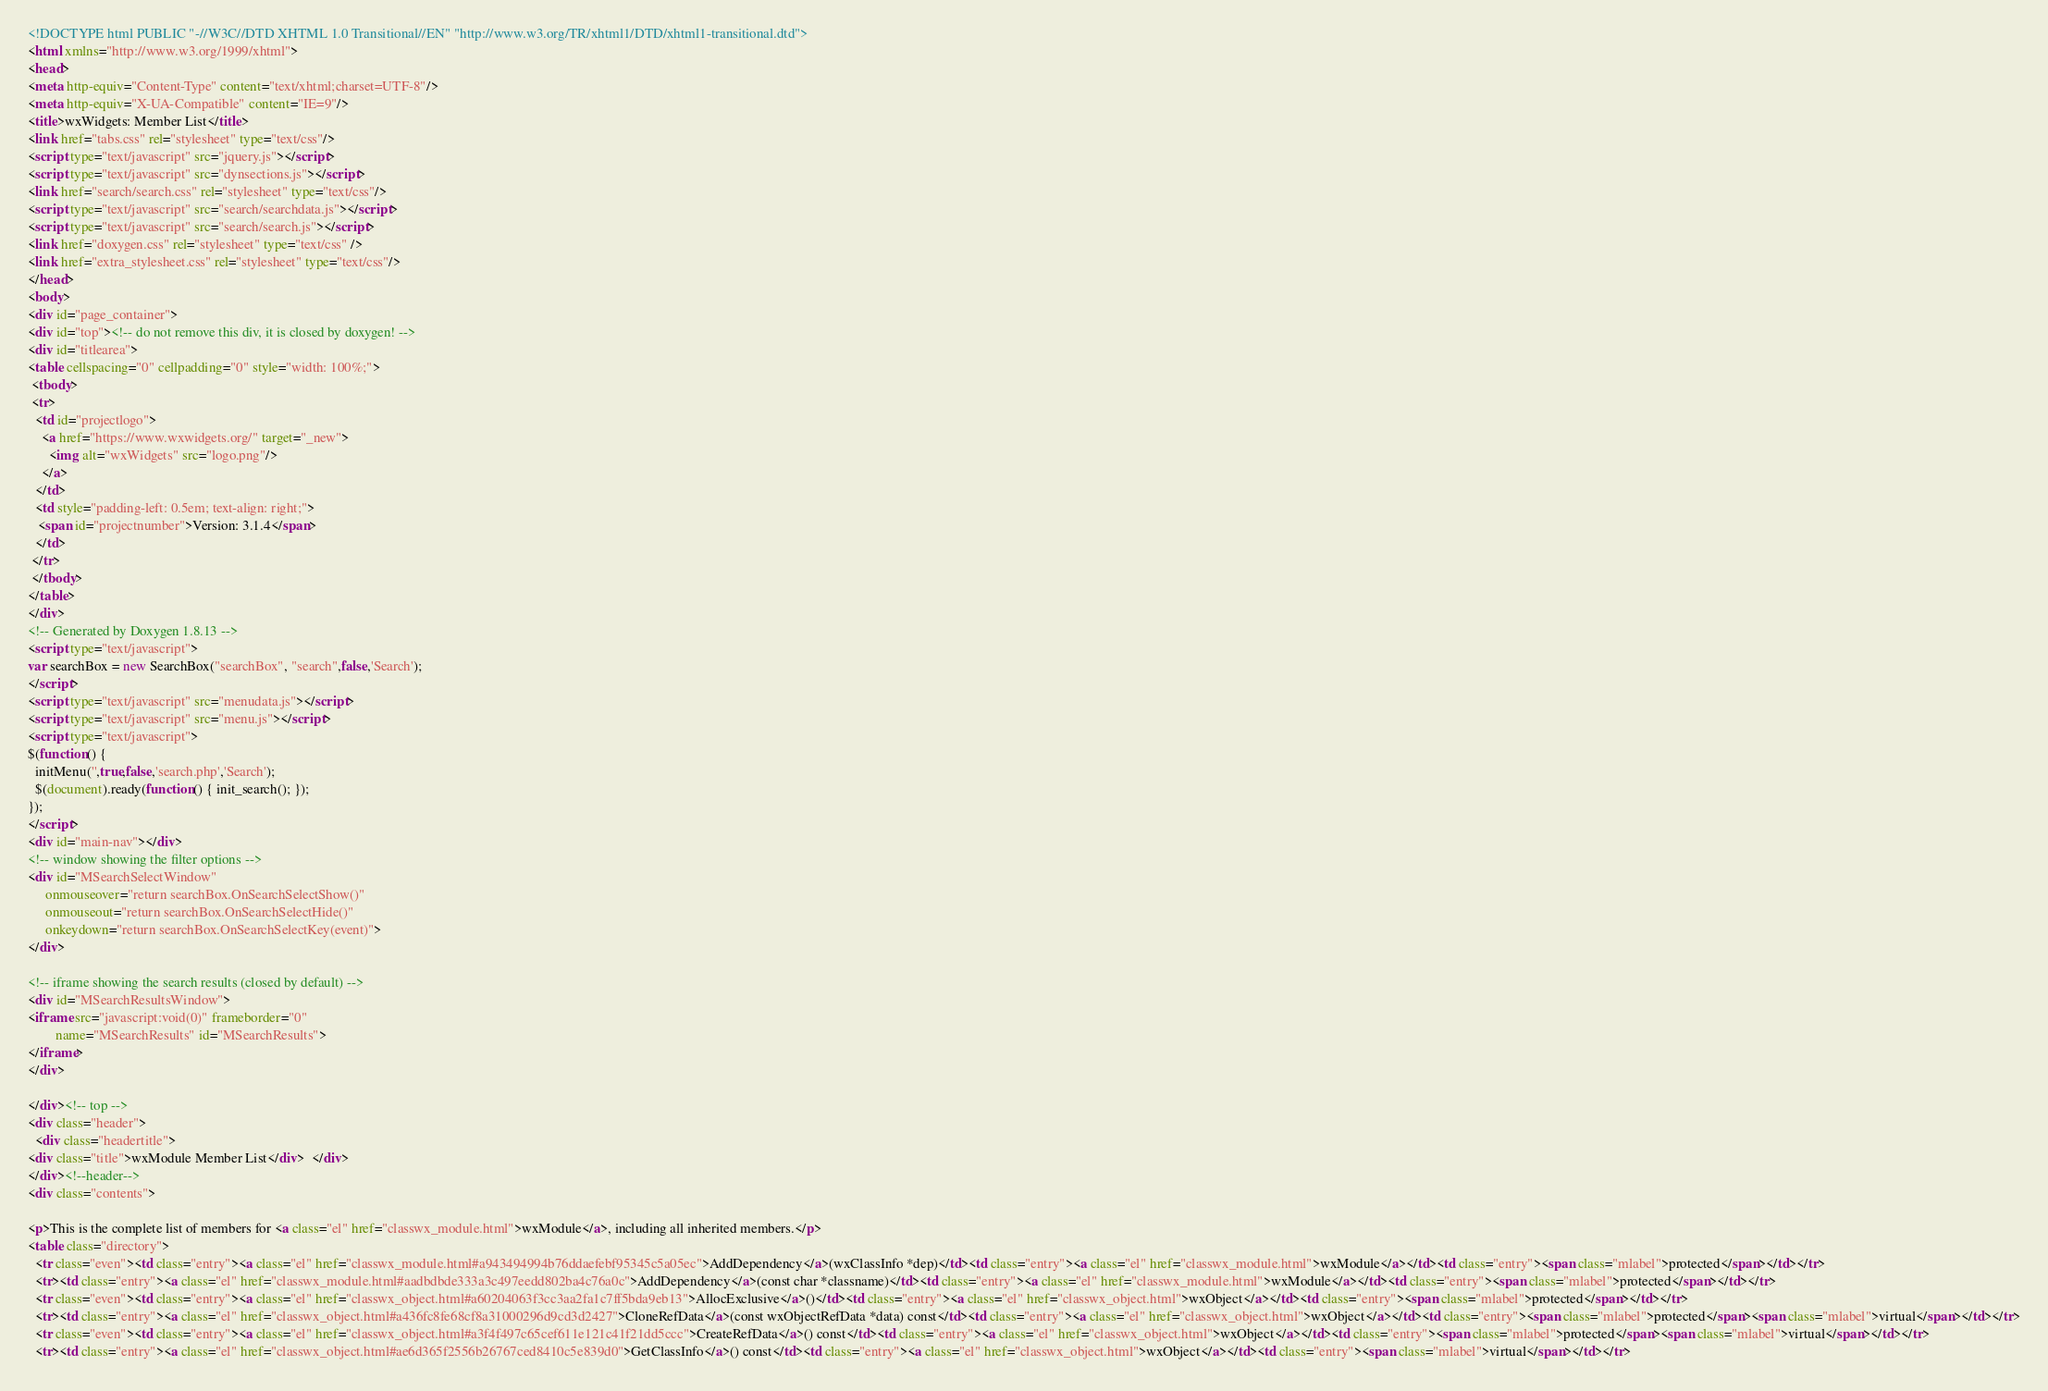Convert code to text. <code><loc_0><loc_0><loc_500><loc_500><_HTML_><!DOCTYPE html PUBLIC "-//W3C//DTD XHTML 1.0 Transitional//EN" "http://www.w3.org/TR/xhtml1/DTD/xhtml1-transitional.dtd">
<html xmlns="http://www.w3.org/1999/xhtml">
<head>
<meta http-equiv="Content-Type" content="text/xhtml;charset=UTF-8"/>
<meta http-equiv="X-UA-Compatible" content="IE=9"/>
<title>wxWidgets: Member List</title>
<link href="tabs.css" rel="stylesheet" type="text/css"/>
<script type="text/javascript" src="jquery.js"></script>
<script type="text/javascript" src="dynsections.js"></script>
<link href="search/search.css" rel="stylesheet" type="text/css"/>
<script type="text/javascript" src="search/searchdata.js"></script>
<script type="text/javascript" src="search/search.js"></script>
<link href="doxygen.css" rel="stylesheet" type="text/css" />
<link href="extra_stylesheet.css" rel="stylesheet" type="text/css"/>
</head>
<body>
<div id="page_container">
<div id="top"><!-- do not remove this div, it is closed by doxygen! -->
<div id="titlearea">
<table cellspacing="0" cellpadding="0" style="width: 100%;">
 <tbody>
 <tr>
  <td id="projectlogo">
    <a href="https://www.wxwidgets.org/" target="_new">
      <img alt="wxWidgets" src="logo.png"/>
    </a>
  </td>
  <td style="padding-left: 0.5em; text-align: right;">
   <span id="projectnumber">Version: 3.1.4</span>
  </td>
 </tr>
 </tbody>
</table>
</div>
<!-- Generated by Doxygen 1.8.13 -->
<script type="text/javascript">
var searchBox = new SearchBox("searchBox", "search",false,'Search');
</script>
<script type="text/javascript" src="menudata.js"></script>
<script type="text/javascript" src="menu.js"></script>
<script type="text/javascript">
$(function() {
  initMenu('',true,false,'search.php','Search');
  $(document).ready(function() { init_search(); });
});
</script>
<div id="main-nav"></div>
<!-- window showing the filter options -->
<div id="MSearchSelectWindow"
     onmouseover="return searchBox.OnSearchSelectShow()"
     onmouseout="return searchBox.OnSearchSelectHide()"
     onkeydown="return searchBox.OnSearchSelectKey(event)">
</div>

<!-- iframe showing the search results (closed by default) -->
<div id="MSearchResultsWindow">
<iframe src="javascript:void(0)" frameborder="0" 
        name="MSearchResults" id="MSearchResults">
</iframe>
</div>

</div><!-- top -->
<div class="header">
  <div class="headertitle">
<div class="title">wxModule Member List</div>  </div>
</div><!--header-->
<div class="contents">

<p>This is the complete list of members for <a class="el" href="classwx_module.html">wxModule</a>, including all inherited members.</p>
<table class="directory">
  <tr class="even"><td class="entry"><a class="el" href="classwx_module.html#a943494994b76ddaefebf95345c5a05ec">AddDependency</a>(wxClassInfo *dep)</td><td class="entry"><a class="el" href="classwx_module.html">wxModule</a></td><td class="entry"><span class="mlabel">protected</span></td></tr>
  <tr><td class="entry"><a class="el" href="classwx_module.html#aadbdbde333a3c497eedd802ba4c76a0c">AddDependency</a>(const char *classname)</td><td class="entry"><a class="el" href="classwx_module.html">wxModule</a></td><td class="entry"><span class="mlabel">protected</span></td></tr>
  <tr class="even"><td class="entry"><a class="el" href="classwx_object.html#a60204063f3cc3aa2fa1c7ff5bda9eb13">AllocExclusive</a>()</td><td class="entry"><a class="el" href="classwx_object.html">wxObject</a></td><td class="entry"><span class="mlabel">protected</span></td></tr>
  <tr><td class="entry"><a class="el" href="classwx_object.html#a436fc8fe68cf8a31000296d9cd3d2427">CloneRefData</a>(const wxObjectRefData *data) const</td><td class="entry"><a class="el" href="classwx_object.html">wxObject</a></td><td class="entry"><span class="mlabel">protected</span><span class="mlabel">virtual</span></td></tr>
  <tr class="even"><td class="entry"><a class="el" href="classwx_object.html#a3f4f497c65cef611e121c41f21dd5ccc">CreateRefData</a>() const</td><td class="entry"><a class="el" href="classwx_object.html">wxObject</a></td><td class="entry"><span class="mlabel">protected</span><span class="mlabel">virtual</span></td></tr>
  <tr><td class="entry"><a class="el" href="classwx_object.html#ae6d365f2556b26767ced8410c5e839d0">GetClassInfo</a>() const</td><td class="entry"><a class="el" href="classwx_object.html">wxObject</a></td><td class="entry"><span class="mlabel">virtual</span></td></tr></code> 